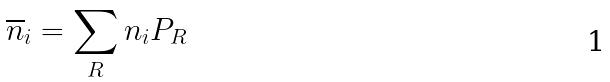<formula> <loc_0><loc_0><loc_500><loc_500>\overline { n } _ { i } = \sum _ { R } n _ { i } P _ { R }</formula> 